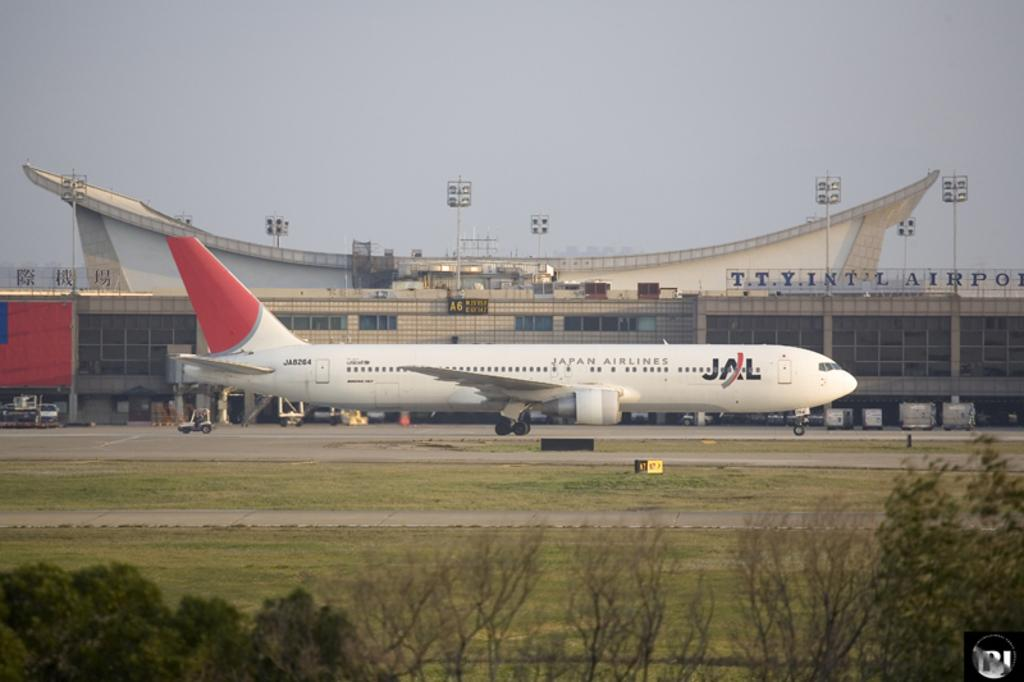<image>
Give a short and clear explanation of the subsequent image. A JAL airplane sits on the runway at the TTY airport. 